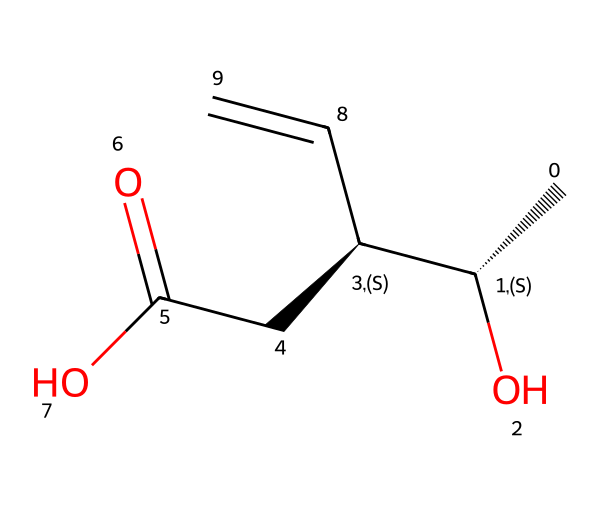What is the molecular formula of the chemical represented by this SMILES? To derive the molecular formula from the SMILES, count the total number of carbon (C), hydrogen (H), and oxygen (O) atoms. The SMILES indicates there are 6 carbon atoms, 10 hydrogen atoms, and 3 oxygen atoms. Thus, the molecular formula is C6H10O3.
Answer: C6H10O3 How many chiral centers are present in this chemical? Analyzing the structure from the SMILES, we identify chiral centers by looking for carbon atoms bonded to four different substituents. In this SMILES, there are two such carbon atoms with different groups attached. Therefore, there are 2 chiral centers.
Answer: 2 What functional groups can be identified in this structure? By examining the SMILES, we see the presence of an alcohol group (indicated by -OH), a carboxylic acid group (indicated by -COOH), and a double bond (C=C). These are the functional groups present.
Answer: alcohol, carboxylic acid, double bond Is this compound a statin? Statins are typically characterized by a specific structure that includes a 3,5-dihydroxy group and a synthetic derivative of natural compounds. The presence of the carboxylic acid and alcohol groups in this structure, along with the overall classification, suggests this compound functions similarly, supporting that it can be considered a statin.
Answer: yes What is the relationship between this compound and cholesterol? Drugs that reduce cholesterol often act by inhibiting the enzyme HMG-CoA reductase, which the structure likely relates to because of its assigned function and classification as a statin. Thus, this compound serves the role of modulating cholesterol levels in the body.
Answer: it lowers cholesterol What is the expected effect of this compound on LDL cholesterol levels? Statins are known to significantly lower low-density lipoprotein (LDL) cholesterol levels, and given that this compound is a statin, it is expected to have a similar effect, contributing to reducing LDL cholesterol in the body.
Answer: decreases LDL cholesterol What type of drug is represented by this chemical structure? Based on the function and structure, which includes specific functional groups associated with lipid metabolism, this compound is categorized as a statin, highlighting its role in managing cholesterol levels.
Answer: statin 